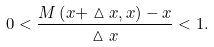Convert formula to latex. <formula><loc_0><loc_0><loc_500><loc_500>0 < \frac { M \left ( x + \vartriangle x , x \right ) - x } { \vartriangle x } < 1 .</formula> 